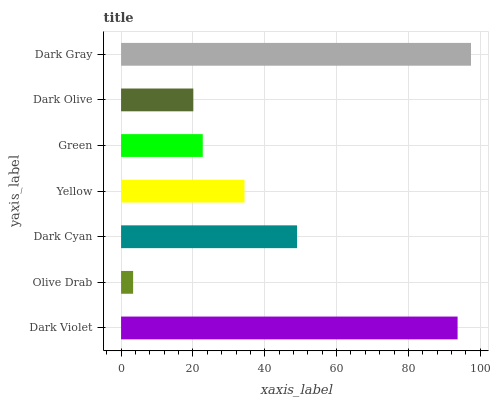Is Olive Drab the minimum?
Answer yes or no. Yes. Is Dark Gray the maximum?
Answer yes or no. Yes. Is Dark Cyan the minimum?
Answer yes or no. No. Is Dark Cyan the maximum?
Answer yes or no. No. Is Dark Cyan greater than Olive Drab?
Answer yes or no. Yes. Is Olive Drab less than Dark Cyan?
Answer yes or no. Yes. Is Olive Drab greater than Dark Cyan?
Answer yes or no. No. Is Dark Cyan less than Olive Drab?
Answer yes or no. No. Is Yellow the high median?
Answer yes or no. Yes. Is Yellow the low median?
Answer yes or no. Yes. Is Dark Gray the high median?
Answer yes or no. No. Is Green the low median?
Answer yes or no. No. 